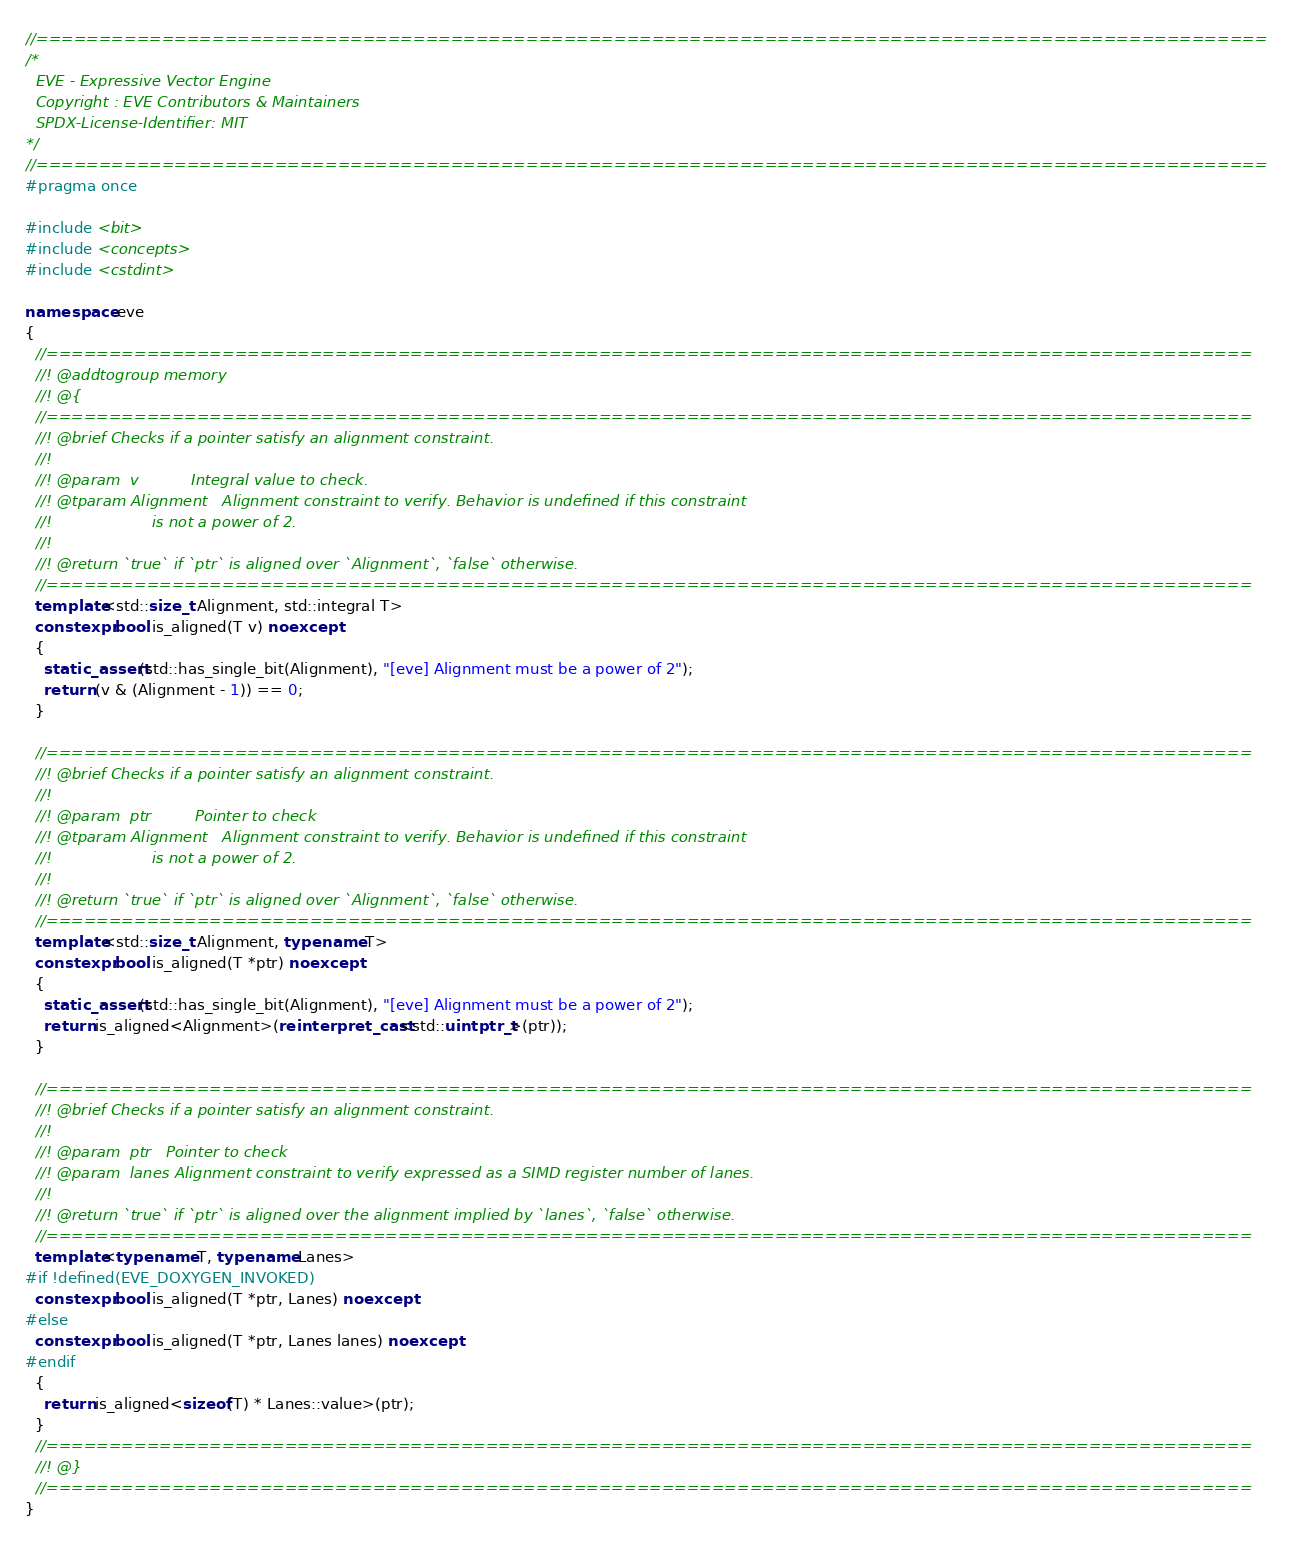<code> <loc_0><loc_0><loc_500><loc_500><_C++_>//==================================================================================================
/*
  EVE - Expressive Vector Engine
  Copyright : EVE Contributors & Maintainers
  SPDX-License-Identifier: MIT
*/
//==================================================================================================
#pragma once

#include <bit>
#include <concepts>
#include <cstdint>

namespace eve
{
  //================================================================================================
  //! @addtogroup memory
  //! @{
  //================================================================================================
  //! @brief Checks if a pointer satisfy an alignment constraint.
  //!
  //! @param  v           Integral value to check.
  //! @tparam Alignment   Alignment constraint to verify. Behavior is undefined if this constraint
  //!                     is not a power of 2.
  //!
  //! @return `true` if `ptr` is aligned over `Alignment`, `false` otherwise.
  //================================================================================================
  template<std::size_t Alignment, std::integral T>
  constexpr bool is_aligned(T v) noexcept
  {
    static_assert(std::has_single_bit(Alignment), "[eve] Alignment must be a power of 2");
    return (v & (Alignment - 1)) == 0;
  }

  //================================================================================================
  //! @brief Checks if a pointer satisfy an alignment constraint.
  //!
  //! @param  ptr         Pointer to check
  //! @tparam Alignment   Alignment constraint to verify. Behavior is undefined if this constraint
  //!                     is not a power of 2.
  //!
  //! @return `true` if `ptr` is aligned over `Alignment`, `false` otherwise.
  //================================================================================================
  template<std::size_t Alignment, typename T>
  constexpr bool is_aligned(T *ptr) noexcept
  {
    static_assert(std::has_single_bit(Alignment), "[eve] Alignment must be a power of 2");
    return is_aligned<Alignment>(reinterpret_cast<std::uintptr_t>(ptr));
  }

  //================================================================================================
  //! @brief Checks if a pointer satisfy an alignment constraint.
  //!
  //! @param  ptr   Pointer to check
  //! @param  lanes Alignment constraint to verify expressed as a SIMD register number of lanes.
  //!
  //! @return `true` if `ptr` is aligned over the alignment implied by `lanes`, `false` otherwise.
  //================================================================================================
  template<typename T, typename Lanes>
#if !defined(EVE_DOXYGEN_INVOKED)
  constexpr bool is_aligned(T *ptr, Lanes) noexcept
#else
  constexpr bool is_aligned(T *ptr, Lanes lanes) noexcept
#endif
  {
    return is_aligned<sizeof(T) * Lanes::value>(ptr);
  }
  //================================================================================================
  //! @}
  //================================================================================================
}
</code> 